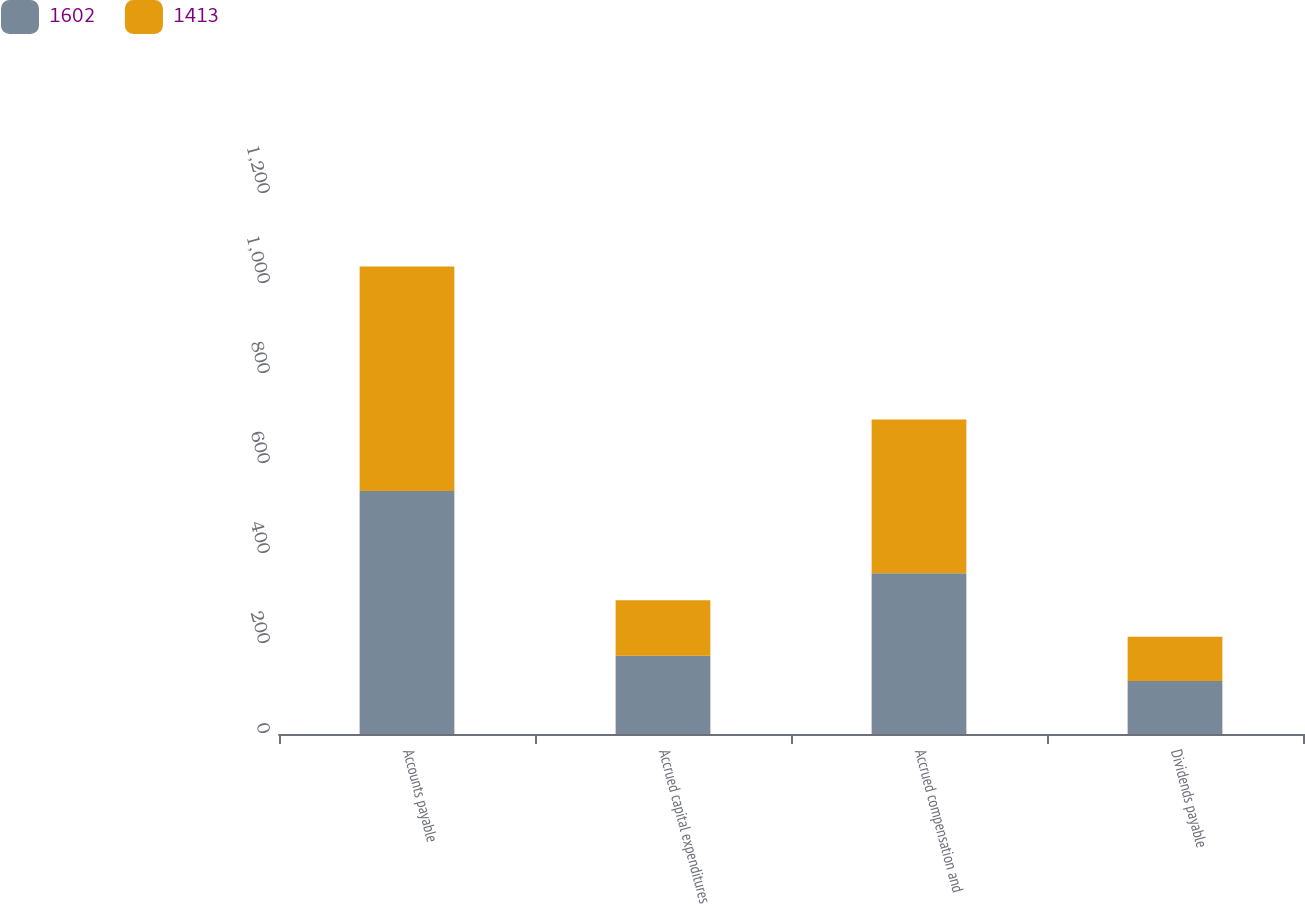Convert chart to OTSL. <chart><loc_0><loc_0><loc_500><loc_500><stacked_bar_chart><ecel><fcel>Accounts payable<fcel>Accrued capital expenditures<fcel>Accrued compensation and<fcel>Dividends payable<nl><fcel>1602<fcel>540<fcel>174<fcel>357<fcel>118<nl><fcel>1413<fcel>499<fcel>123<fcel>342<fcel>98<nl></chart> 